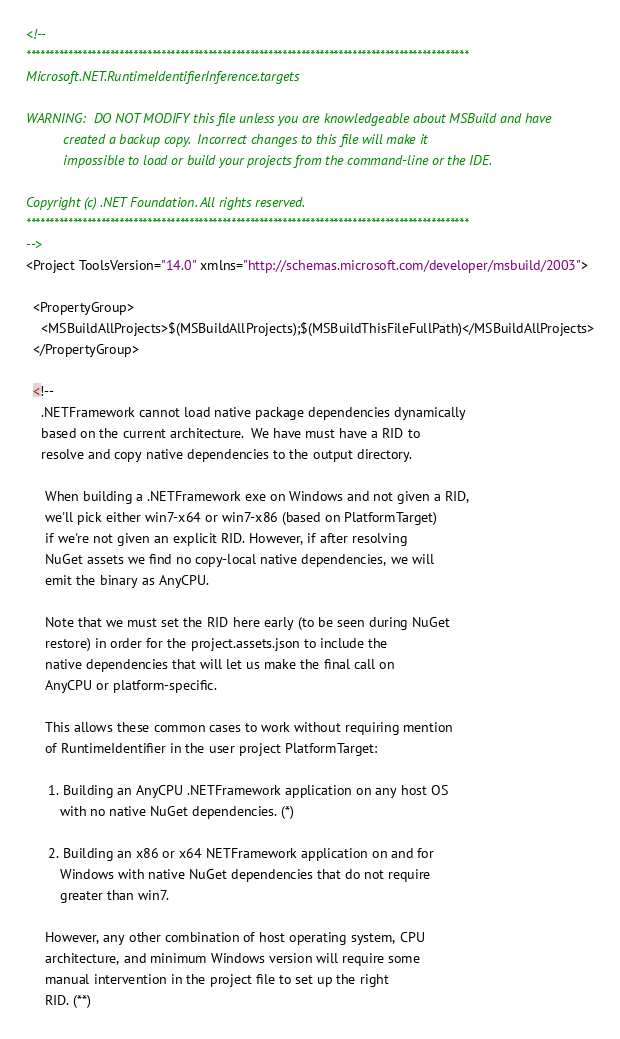<code> <loc_0><loc_0><loc_500><loc_500><_XML_><!--
***********************************************************************************************
Microsoft.NET.RuntimeIdentifierInference.targets

WARNING:  DO NOT MODIFY this file unless you are knowledgeable about MSBuild and have
          created a backup copy.  Incorrect changes to this file will make it
          impossible to load or build your projects from the command-line or the IDE.

Copyright (c) .NET Foundation. All rights reserved. 
***********************************************************************************************
-->
<Project ToolsVersion="14.0" xmlns="http://schemas.microsoft.com/developer/msbuild/2003">

  <PropertyGroup>
    <MSBuildAllProjects>$(MSBuildAllProjects);$(MSBuildThisFileFullPath)</MSBuildAllProjects>
  </PropertyGroup>

  <!--
    .NETFramework cannot load native package dependencies dynamically
    based on the current architecture.  We have must have a RID to
    resolve and copy native dependencies to the output directory.

     When building a .NETFramework exe on Windows and not given a RID,
     we'll pick either win7-x64 or win7-x86 (based on PlatformTarget)
     if we're not given an explicit RID. However, if after resolving
     NuGet assets we find no copy-local native dependencies, we will
     emit the binary as AnyCPU.

     Note that we must set the RID here early (to be seen during NuGet
     restore) in order for the project.assets.json to include the
     native dependencies that will let us make the final call on
     AnyCPU or platform-specific.

     This allows these common cases to work without requiring mention
     of RuntimeIdentifier in the user project PlatformTarget:

      1. Building an AnyCPU .NETFramework application on any host OS
         with no native NuGet dependencies. (*)

      2. Building an x86 or x64 NETFramework application on and for
         Windows with native NuGet dependencies that do not require
         greater than win7.

     However, any other combination of host operating system, CPU
     architecture, and minimum Windows version will require some
     manual intervention in the project file to set up the right
     RID. (**)
</code> 